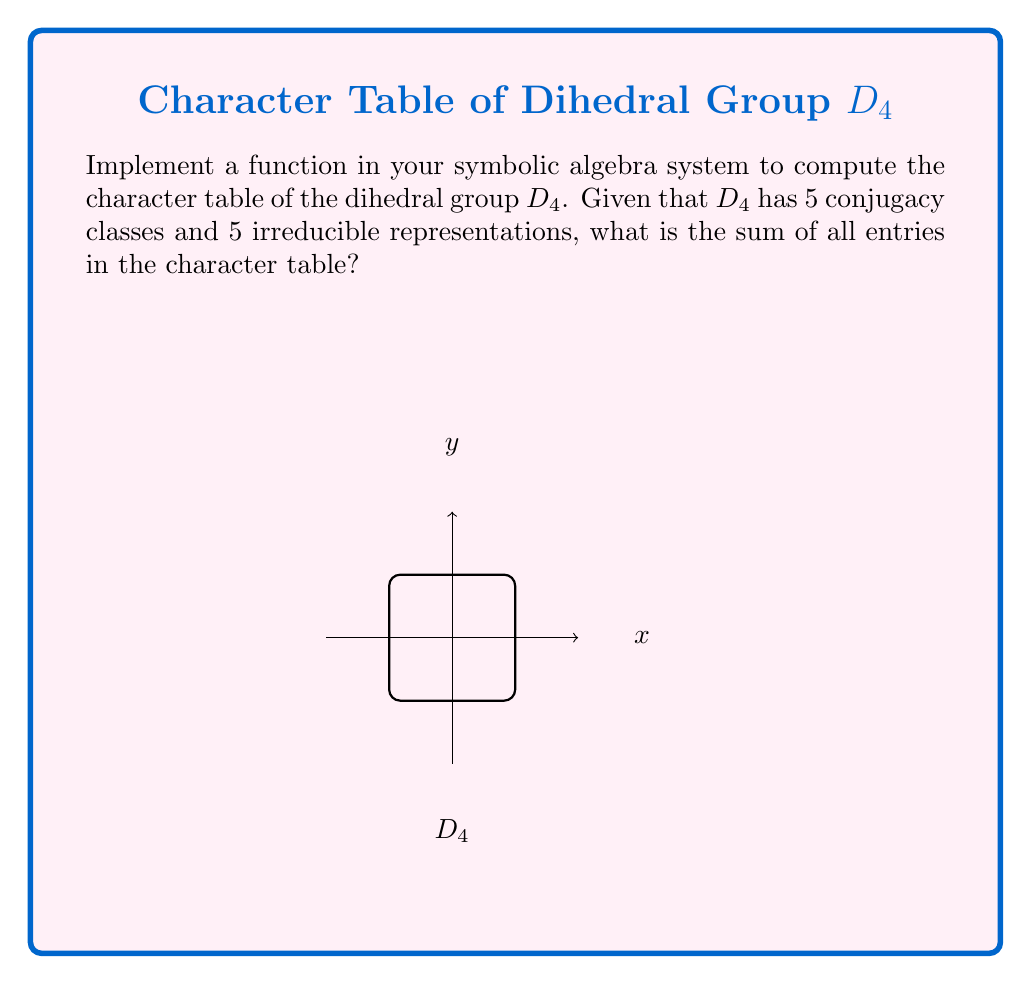What is the answer to this math problem? To solve this problem, we need to follow these steps:

1) First, let's recall the structure of $D_4$. It has 8 elements: the identity, 3 rotations, and 4 reflections.

2) The 5 conjugacy classes of $D_4$ are:
   - $\{e\}$ (identity)
   - $\{r^2\}$ (180° rotation)
   - $\{r, r^3\}$ (90° rotations)
   - $\{s, sr^2\}$ (reflections across diagonals)
   - $\{sr, sr^3\}$ (reflections across axes)

3) The character table for $D_4$ is:

   $$
   \begin{array}{c|ccccc}
    D_4 & \{e\} & \{r^2\} & \{r, r^3\} & \{s, sr^2\} & \{sr, sr^3\} \\
   \hline
   \chi_1 & 1 & 1 & 1 & 1 & 1 \\
   \chi_2 & 1 & 1 & 1 & -1 & -1 \\
   \chi_3 & 1 & 1 & -1 & 1 & -1 \\
   \chi_4 & 1 & 1 & -1 & -1 & 1 \\
   \chi_5 & 2 & -2 & 0 & 0 & 0
   \end{array}
   $$

4) To find the sum of all entries, we need to add up all the numbers in this table.

5) Sum of entries in each row:
   - $\chi_1$: $1 + 1 + 1 + 1 + 1 = 5$
   - $\chi_2$: $1 + 1 + 1 - 1 - 1 = 1$
   - $\chi_3$: $1 + 1 - 1 + 1 - 1 = 1$
   - $\chi_4$: $1 + 1 - 1 - 1 + 1 = 1$
   - $\chi_5$: $2 - 2 + 0 + 0 + 0 = 0$

6) Total sum: $5 + 1 + 1 + 1 + 0 = 8$

Therefore, the sum of all entries in the character table of $D_4$ is 8.
Answer: 8 